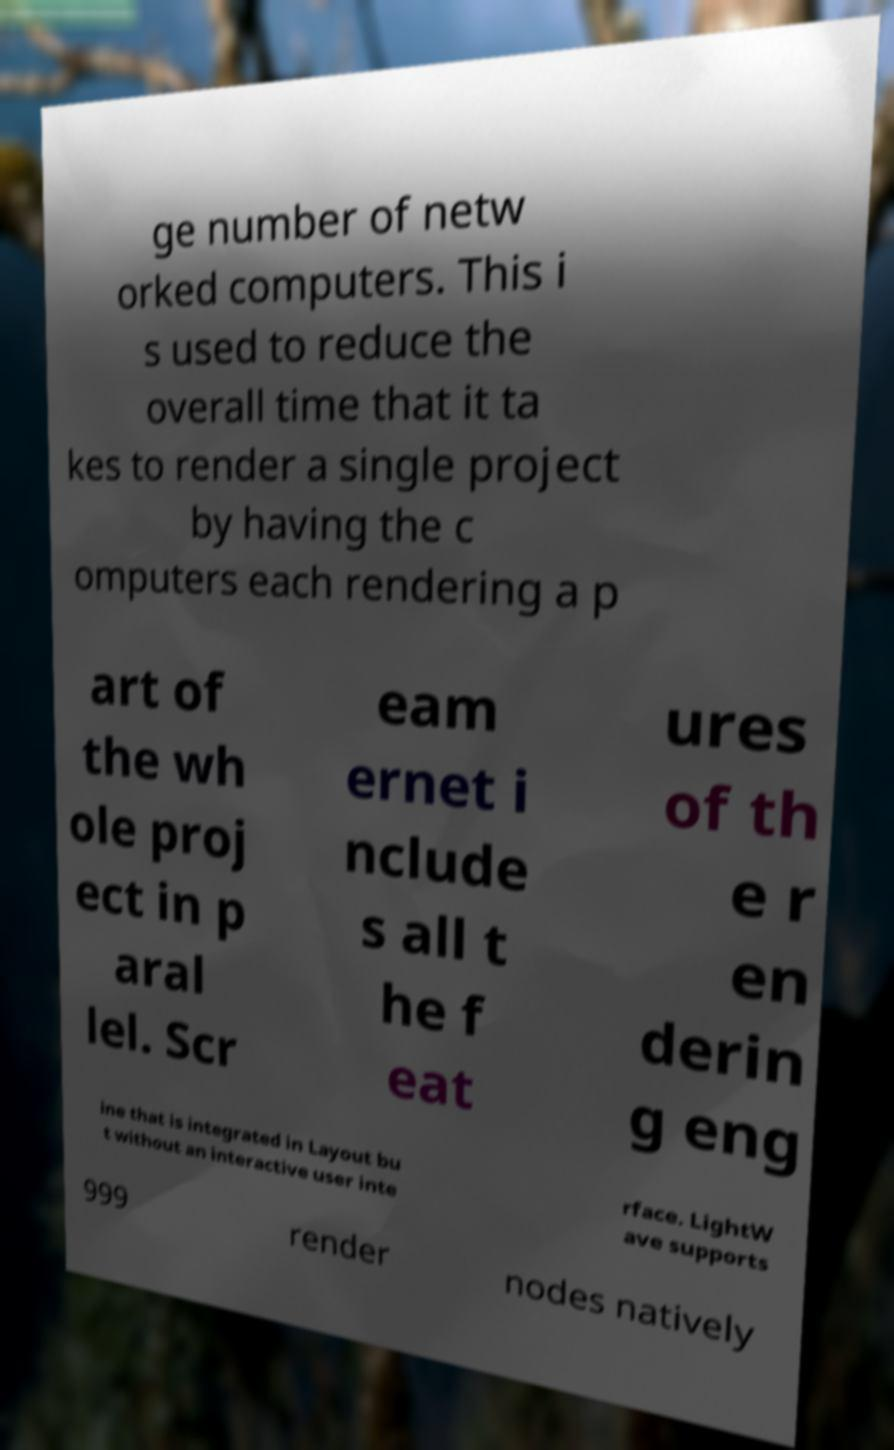I need the written content from this picture converted into text. Can you do that? ge number of netw orked computers. This i s used to reduce the overall time that it ta kes to render a single project by having the c omputers each rendering a p art of the wh ole proj ect in p aral lel. Scr eam ernet i nclude s all t he f eat ures of th e r en derin g eng ine that is integrated in Layout bu t without an interactive user inte rface. LightW ave supports 999 render nodes natively 